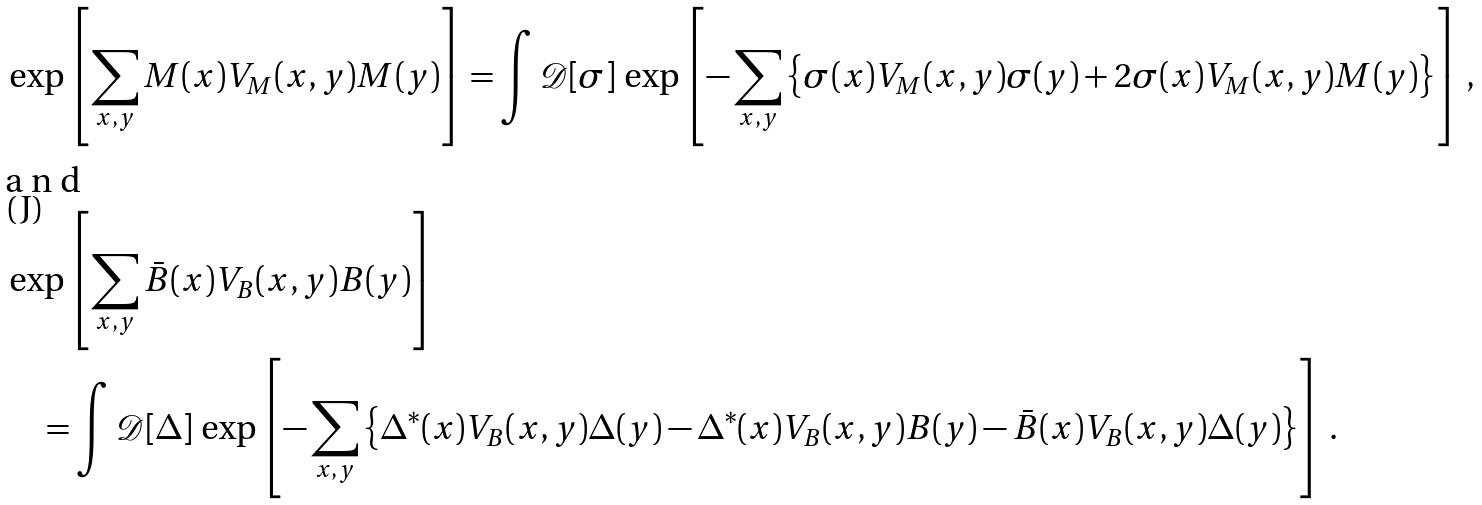<formula> <loc_0><loc_0><loc_500><loc_500>& \exp \left [ \sum _ { x , y } M ( x ) V _ { M } ( x , y ) M ( y ) \right ] = \int \mathcal { D } [ \sigma ] \, \exp \left [ - \sum _ { x , y } \left \{ \sigma ( x ) V _ { M } ( x , y ) \sigma ( y ) + 2 \sigma ( x ) V _ { M } ( x , y ) M ( y ) \right \} \right ] \, , \intertext { a n d } & \exp \left [ \sum _ { x , y } \bar { B } ( x ) V _ { B } ( x , y ) B ( y ) \right ] \\ & \quad = \int \mathcal { D } [ \Delta ] \, \exp \left [ - \sum _ { x , y } \left \{ \Delta ^ { \ast } ( x ) V _ { B } ( x , y ) \Delta ( y ) - \Delta ^ { \ast } ( x ) V _ { B } ( x , y ) B ( y ) - \bar { B } ( x ) V _ { B } ( x , y ) \Delta ( y ) \right \} \right ] \, .</formula> 